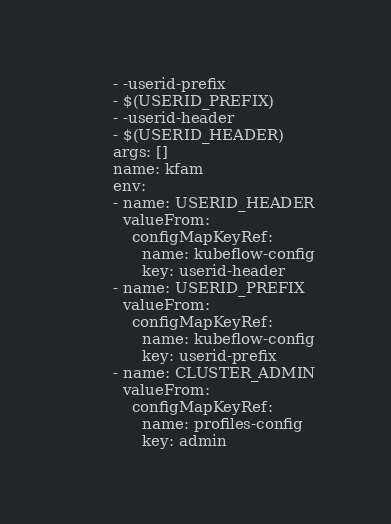Convert code to text. <code><loc_0><loc_0><loc_500><loc_500><_YAML_>        - -userid-prefix 
        - $(USERID_PREFIX)
        - -userid-header
        - $(USERID_HEADER)
        args: []
        name: kfam
        env:
        - name: USERID_HEADER
          valueFrom:
            configMapKeyRef:
              name: kubeflow-config
              key: userid-header
        - name: USERID_PREFIX
          valueFrom:
            configMapKeyRef:
              name: kubeflow-config
              key: userid-prefix
        - name: CLUSTER_ADMIN
          valueFrom:
            configMapKeyRef:
              name: profiles-config
              key: admin
</code> 